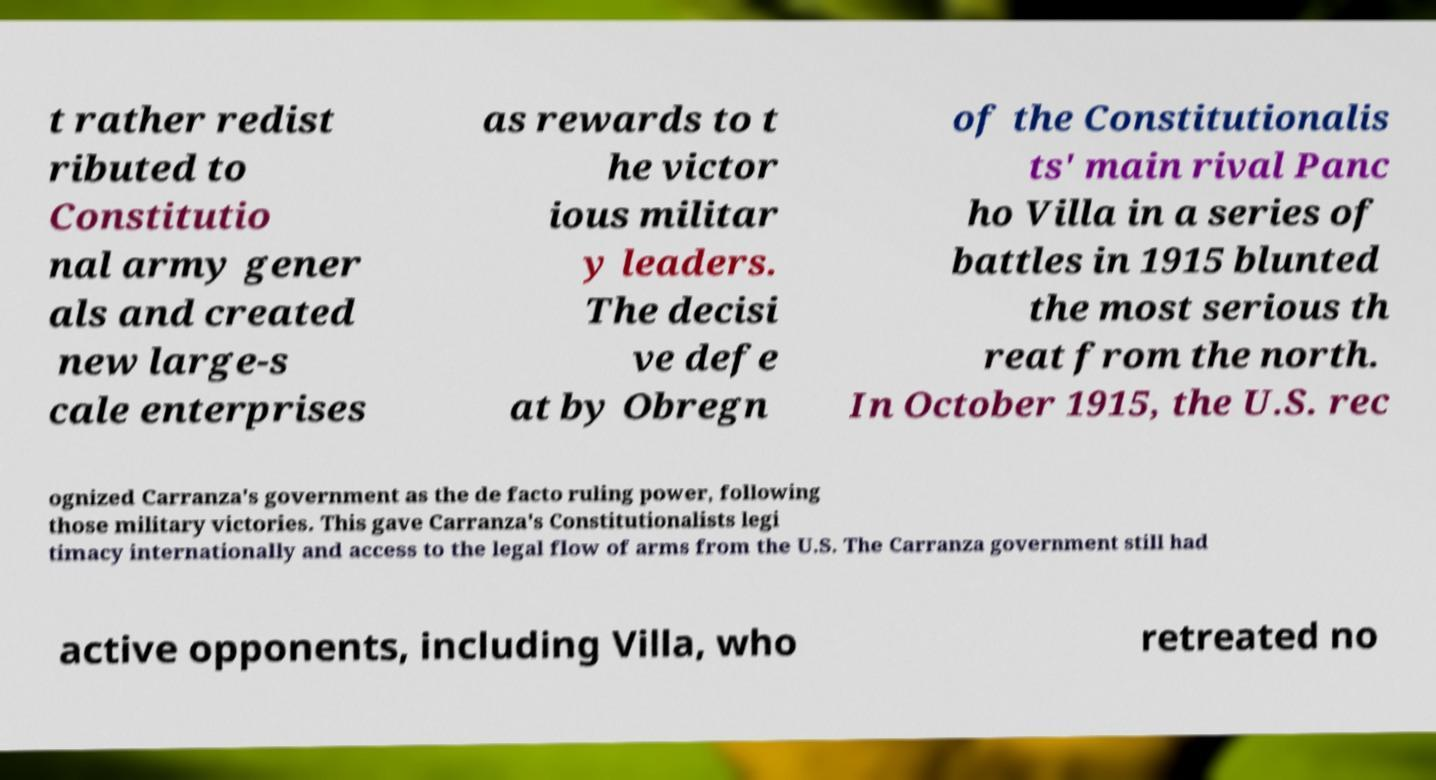Please identify and transcribe the text found in this image. t rather redist ributed to Constitutio nal army gener als and created new large-s cale enterprises as rewards to t he victor ious militar y leaders. The decisi ve defe at by Obregn of the Constitutionalis ts' main rival Panc ho Villa in a series of battles in 1915 blunted the most serious th reat from the north. In October 1915, the U.S. rec ognized Carranza's government as the de facto ruling power, following those military victories. This gave Carranza's Constitutionalists legi timacy internationally and access to the legal flow of arms from the U.S. The Carranza government still had active opponents, including Villa, who retreated no 